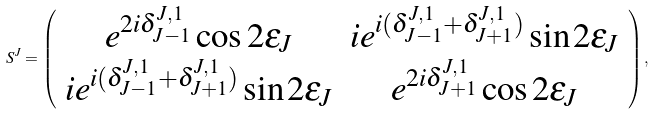<formula> <loc_0><loc_0><loc_500><loc_500>S ^ { J } = \left ( \begin{array} { c c } e ^ { 2 i \delta ^ { J , 1 } _ { J - 1 } } \cos { 2 \epsilon _ { J } } & i e ^ { i ( \delta ^ { J , 1 } _ { J - 1 } + \delta ^ { J , 1 } _ { J + 1 } ) } \sin { 2 \epsilon _ { J } } \\ i e ^ { i ( \delta ^ { J , 1 } _ { J - 1 } + \delta ^ { J , 1 } _ { J + 1 } ) } \sin { 2 \epsilon _ { J } } & e ^ { 2 i \delta ^ { J , 1 } _ { J + 1 } } \cos { 2 \epsilon _ { J } } \end{array} \right ) ,</formula> 